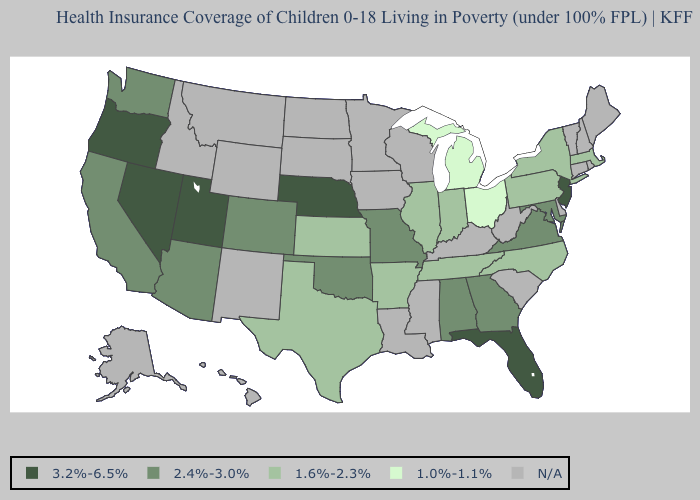Name the states that have a value in the range 3.2%-6.5%?
Short answer required. Florida, Nebraska, Nevada, New Jersey, Oregon, Utah. What is the lowest value in the MidWest?
Quick response, please. 1.0%-1.1%. Which states have the highest value in the USA?
Short answer required. Florida, Nebraska, Nevada, New Jersey, Oregon, Utah. What is the value of New Mexico?
Answer briefly. N/A. Name the states that have a value in the range 1.0%-1.1%?
Answer briefly. Michigan, Ohio. Does Nevada have the highest value in the West?
Answer briefly. Yes. Among the states that border Maryland , does Virginia have the lowest value?
Answer briefly. No. Which states have the lowest value in the USA?
Keep it brief. Michigan, Ohio. What is the lowest value in states that border New Mexico?
Write a very short answer. 1.6%-2.3%. Which states hav the highest value in the South?
Quick response, please. Florida. Name the states that have a value in the range 1.6%-2.3%?
Give a very brief answer. Arkansas, Illinois, Indiana, Kansas, Massachusetts, New York, North Carolina, Pennsylvania, Tennessee, Texas. Which states have the lowest value in the USA?
Concise answer only. Michigan, Ohio. Among the states that border New Mexico , which have the lowest value?
Be succinct. Texas. Which states have the highest value in the USA?
Be succinct. Florida, Nebraska, Nevada, New Jersey, Oregon, Utah. 